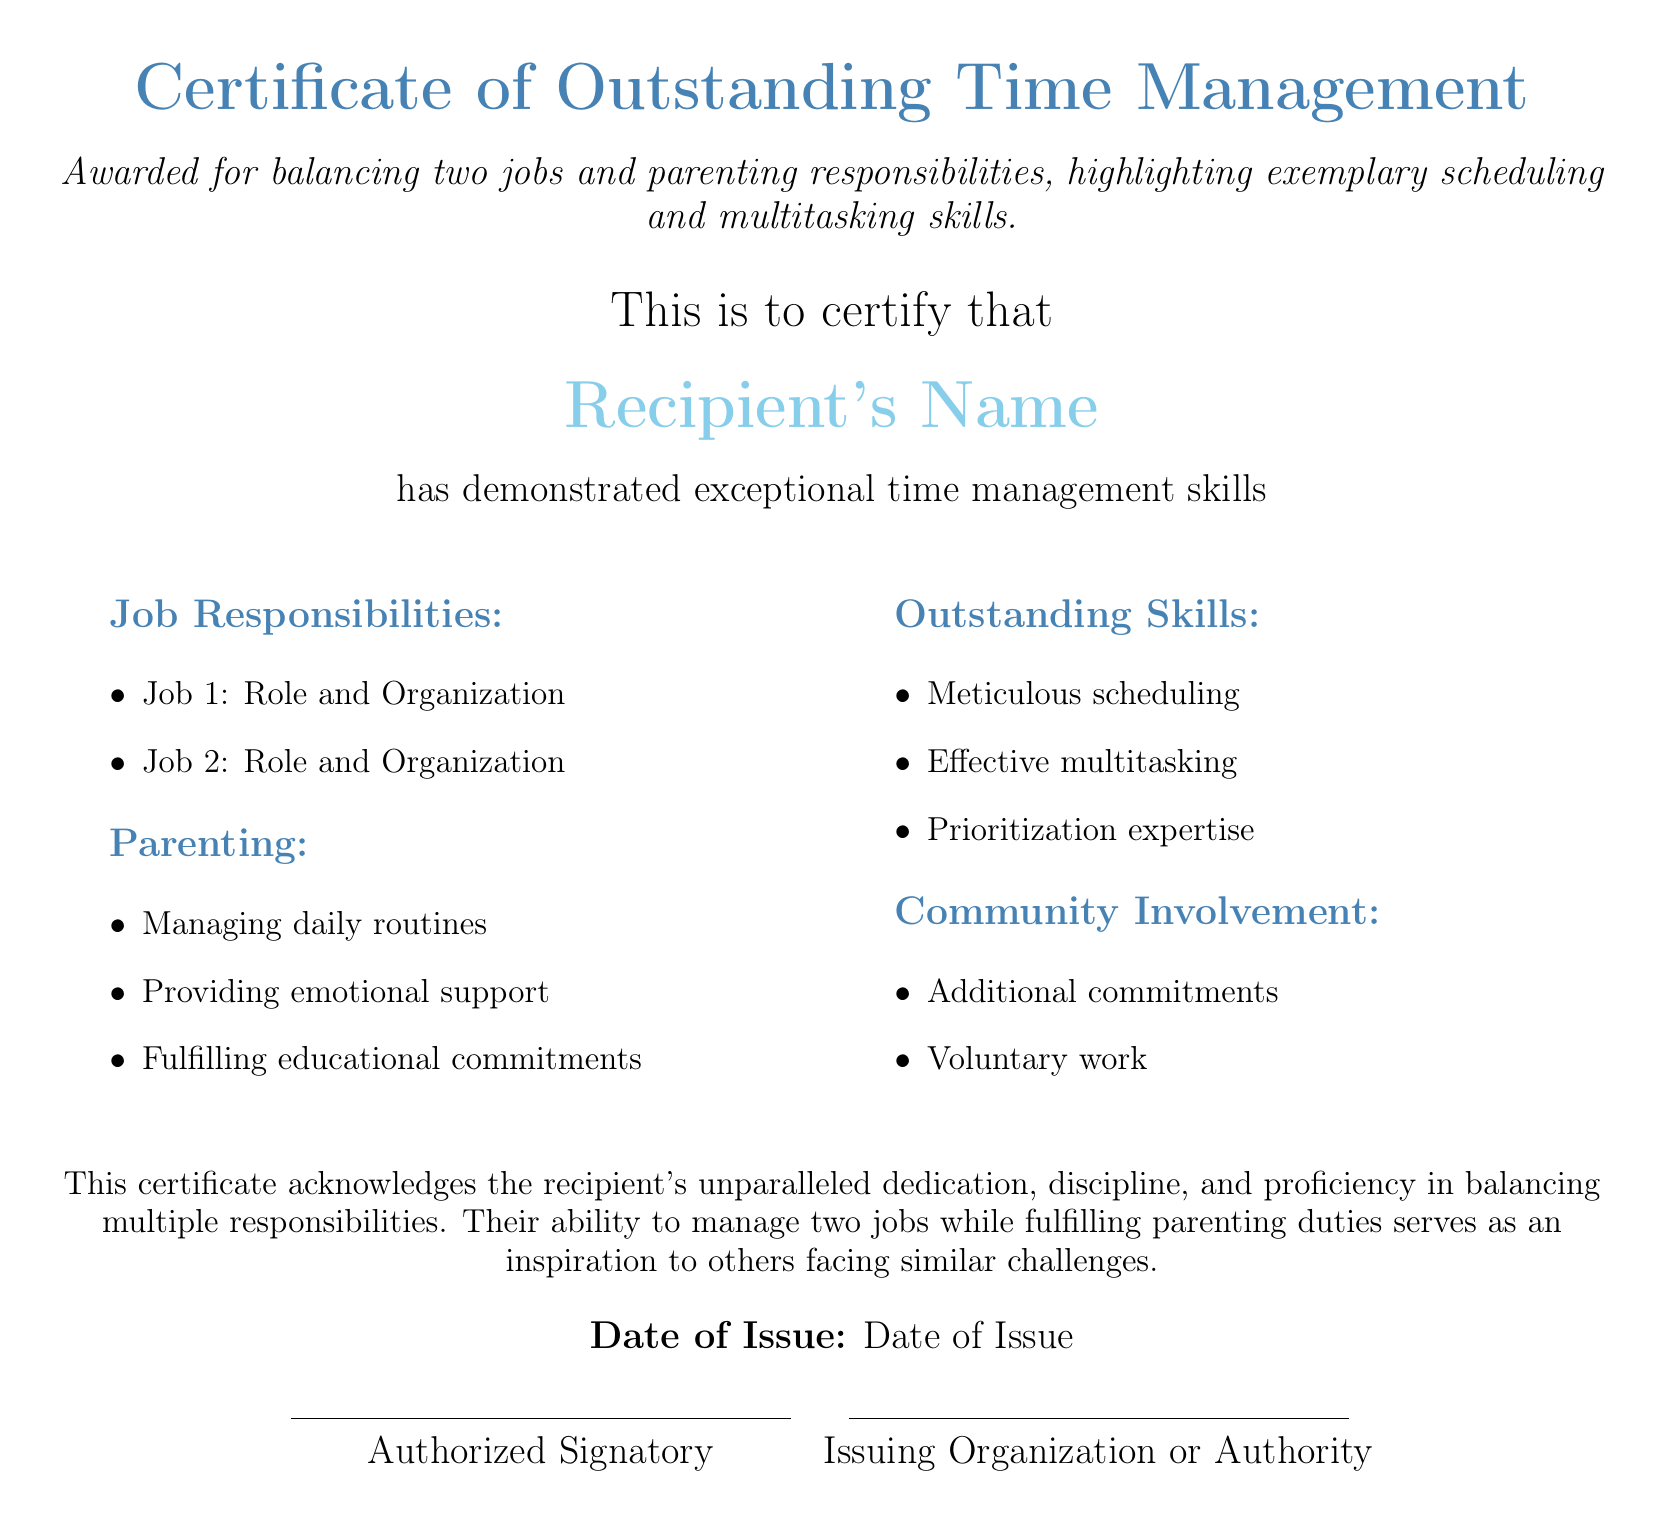What is the title of the certificate? The title of the certificate is presented at the top of the document.
Answer: Certificate of Outstanding Time Management Who is the recipient of the certificate? The recipient's name is highlighted in the document for recognition.
Answer: Recipient's Name What are the two job roles mentioned? The document lists the responsibilities under "Job Responsibilities."
Answer: Job 1: Role and Organization, Job 2: Role and Organization What is one of the responsibilities listed under Parenting? Parenting responsibilities are specified in a bullet list within the document.
Answer: Managing daily routines What skill is highlighted as part of Outstanding Skills? The skills section includes key competencies demonstrated by the recipient.
Answer: Effective multitasking Which organization issued the certificate? The issuing organization is stated below the authorized signatory.
Answer: Issuing Organization or Authority What is the date of issue for the certificate? The date of issue is explicitly stated near the bottom of the document.
Answer: Date of Issue What is one aspect of community involvement noted in the document? The community involvement section includes activities beyond jobs and parenting.
Answer: Voluntary work How is the achievement described in the certificate? The achievement is characterized in a summary statement after the sections.
Answer: Unparalleled dedication, discipline, and proficiency 